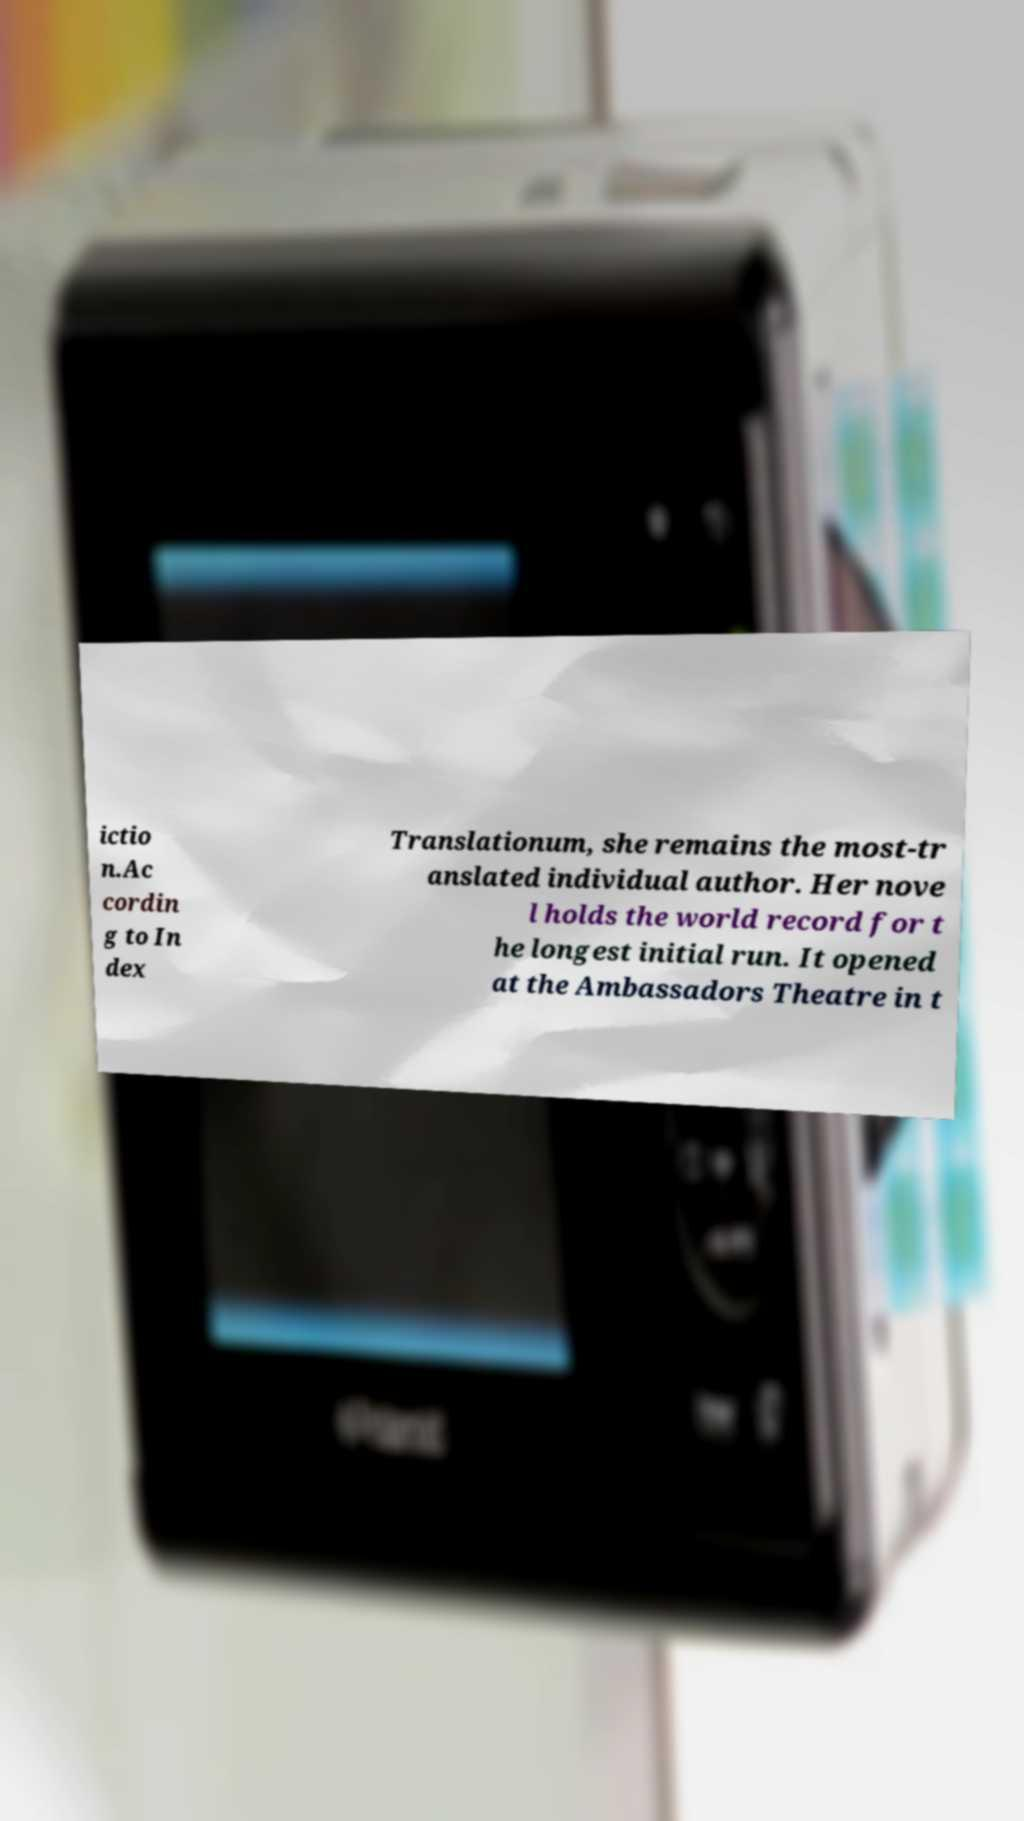Please identify and transcribe the text found in this image. ictio n.Ac cordin g to In dex Translationum, she remains the most-tr anslated individual author. Her nove l holds the world record for t he longest initial run. It opened at the Ambassadors Theatre in t 